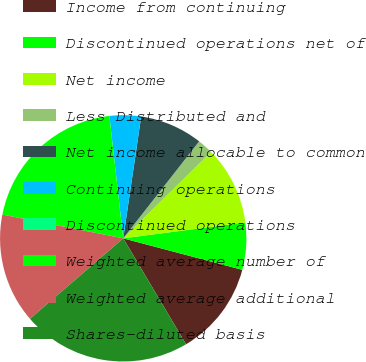Convert chart. <chart><loc_0><loc_0><loc_500><loc_500><pie_chart><fcel>Income from continuing<fcel>Discontinued operations net of<fcel>Net income<fcel>Less Distributed and<fcel>Net income allocable to common<fcel>Continuing operations<fcel>Discontinued operations<fcel>Weighted average number of<fcel>Weighted average additional<fcel>Shares-diluted basis<nl><fcel>12.36%<fcel>6.18%<fcel>10.3%<fcel>2.06%<fcel>8.24%<fcel>4.12%<fcel>0.0%<fcel>20.12%<fcel>14.42%<fcel>22.18%<nl></chart> 